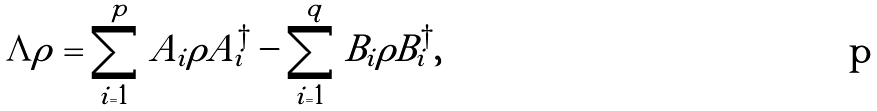Convert formula to latex. <formula><loc_0><loc_0><loc_500><loc_500>\Lambda { \rho } = \sum _ { i = 1 } ^ { p } A _ { i } \rho A _ { i } ^ { \dagger } - \sum _ { i = 1 } ^ { q } B _ { i } \rho B _ { i } ^ { \dagger } ,</formula> 